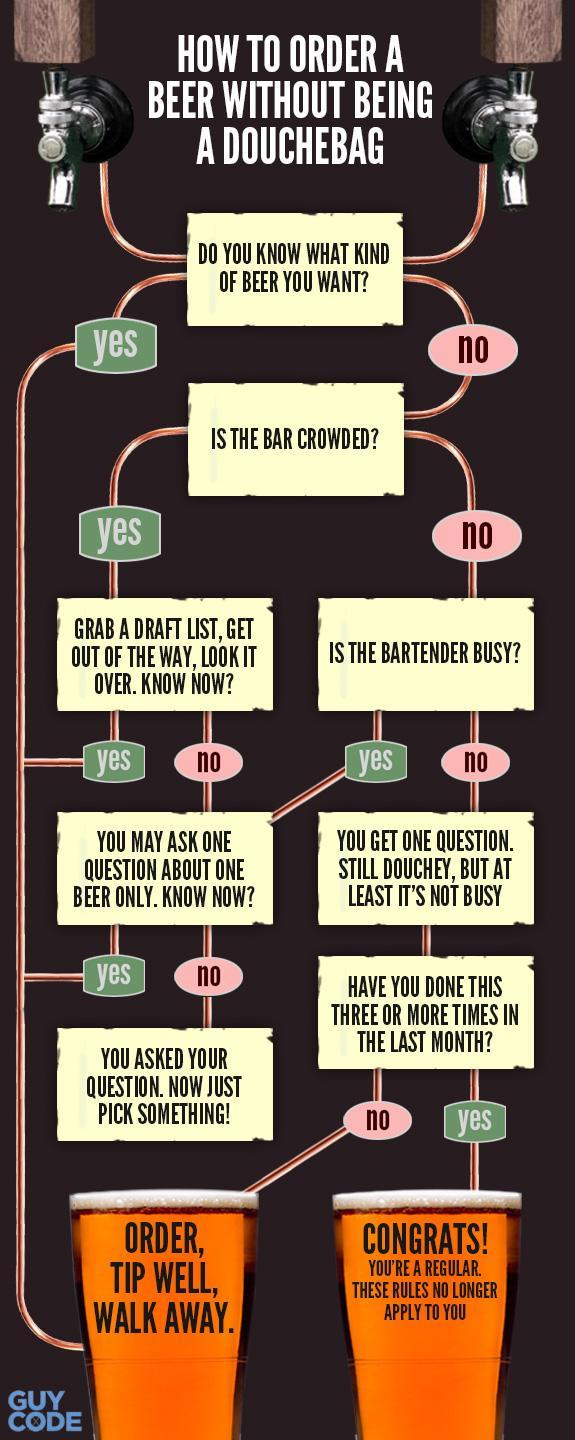how many yes are there in the image
Answer the question with a short phrase. 6 how many taps are shown 2 what happens if you have not done this three or more times in the last month? order, tip well, walk away. what does it mean that these rules no longer apply to you? you're a regular how many beer glasses are shown 2 what do you do if you know what kind of beer you want order, tip well, walk away. 